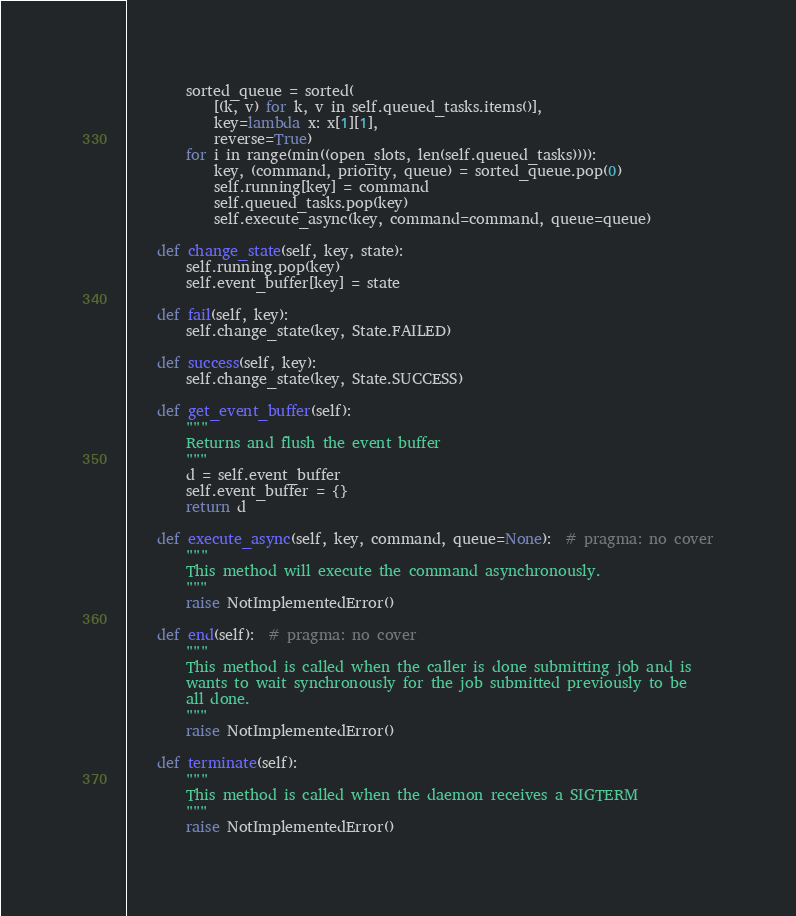Convert code to text. <code><loc_0><loc_0><loc_500><loc_500><_Python_>        sorted_queue = sorted(
            [(k, v) for k, v in self.queued_tasks.items()],
            key=lambda x: x[1][1],
            reverse=True)
        for i in range(min((open_slots, len(self.queued_tasks)))):
            key, (command, priority, queue) = sorted_queue.pop(0)
            self.running[key] = command
            self.queued_tasks.pop(key)
            self.execute_async(key, command=command, queue=queue)

    def change_state(self, key, state):
        self.running.pop(key)
        self.event_buffer[key] = state

    def fail(self, key):
        self.change_state(key, State.FAILED)

    def success(self, key):
        self.change_state(key, State.SUCCESS)

    def get_event_buffer(self):
        """
        Returns and flush the event buffer
        """
        d = self.event_buffer
        self.event_buffer = {}
        return d

    def execute_async(self, key, command, queue=None):  # pragma: no cover
        """
        This method will execute the command asynchronously.
        """
        raise NotImplementedError()

    def end(self):  # pragma: no cover
        """
        This method is called when the caller is done submitting job and is
        wants to wait synchronously for the job submitted previously to be
        all done.
        """
        raise NotImplementedError()

    def terminate(self):
        """
        This method is called when the daemon receives a SIGTERM
        """
        raise NotImplementedError()
</code> 